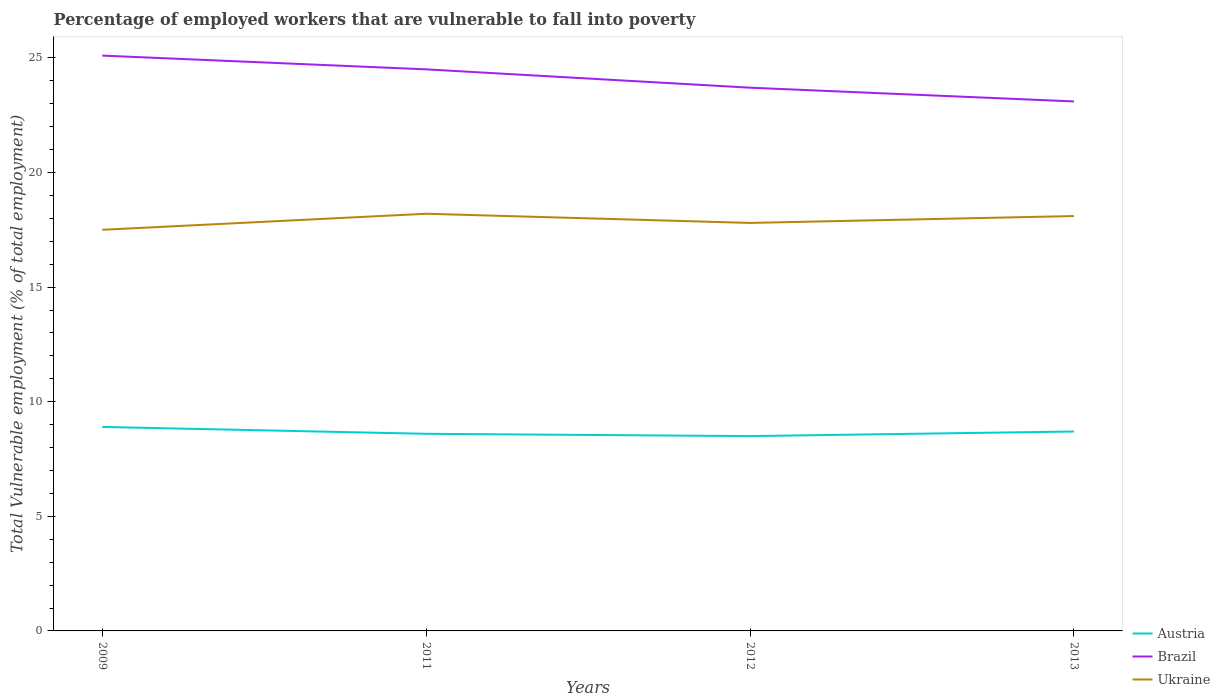Is the number of lines equal to the number of legend labels?
Provide a succinct answer. Yes. In which year was the percentage of employed workers who are vulnerable to fall into poverty in Austria maximum?
Your response must be concise. 2012. What is the total percentage of employed workers who are vulnerable to fall into poverty in Austria in the graph?
Offer a terse response. 0.1. What is the difference between the highest and the second highest percentage of employed workers who are vulnerable to fall into poverty in Ukraine?
Ensure brevity in your answer.  0.7. Is the percentage of employed workers who are vulnerable to fall into poverty in Austria strictly greater than the percentage of employed workers who are vulnerable to fall into poverty in Brazil over the years?
Your response must be concise. Yes. How many years are there in the graph?
Ensure brevity in your answer.  4. Are the values on the major ticks of Y-axis written in scientific E-notation?
Ensure brevity in your answer.  No. Does the graph contain grids?
Your answer should be very brief. No. How many legend labels are there?
Keep it short and to the point. 3. What is the title of the graph?
Offer a terse response. Percentage of employed workers that are vulnerable to fall into poverty. Does "Hong Kong" appear as one of the legend labels in the graph?
Offer a terse response. No. What is the label or title of the Y-axis?
Provide a short and direct response. Total Vulnerable employment (% of total employment). What is the Total Vulnerable employment (% of total employment) of Austria in 2009?
Make the answer very short. 8.9. What is the Total Vulnerable employment (% of total employment) of Brazil in 2009?
Provide a succinct answer. 25.1. What is the Total Vulnerable employment (% of total employment) of Ukraine in 2009?
Give a very brief answer. 17.5. What is the Total Vulnerable employment (% of total employment) in Austria in 2011?
Your response must be concise. 8.6. What is the Total Vulnerable employment (% of total employment) in Ukraine in 2011?
Ensure brevity in your answer.  18.2. What is the Total Vulnerable employment (% of total employment) in Brazil in 2012?
Offer a very short reply. 23.7. What is the Total Vulnerable employment (% of total employment) of Ukraine in 2012?
Your response must be concise. 17.8. What is the Total Vulnerable employment (% of total employment) in Austria in 2013?
Make the answer very short. 8.7. What is the Total Vulnerable employment (% of total employment) of Brazil in 2013?
Provide a succinct answer. 23.1. What is the Total Vulnerable employment (% of total employment) in Ukraine in 2013?
Your answer should be compact. 18.1. Across all years, what is the maximum Total Vulnerable employment (% of total employment) of Austria?
Keep it short and to the point. 8.9. Across all years, what is the maximum Total Vulnerable employment (% of total employment) in Brazil?
Keep it short and to the point. 25.1. Across all years, what is the maximum Total Vulnerable employment (% of total employment) in Ukraine?
Make the answer very short. 18.2. Across all years, what is the minimum Total Vulnerable employment (% of total employment) of Brazil?
Offer a terse response. 23.1. What is the total Total Vulnerable employment (% of total employment) in Austria in the graph?
Your answer should be very brief. 34.7. What is the total Total Vulnerable employment (% of total employment) of Brazil in the graph?
Your answer should be very brief. 96.4. What is the total Total Vulnerable employment (% of total employment) in Ukraine in the graph?
Your answer should be compact. 71.6. What is the difference between the Total Vulnerable employment (% of total employment) of Austria in 2009 and that in 2011?
Your response must be concise. 0.3. What is the difference between the Total Vulnerable employment (% of total employment) of Ukraine in 2009 and that in 2011?
Offer a terse response. -0.7. What is the difference between the Total Vulnerable employment (% of total employment) in Brazil in 2009 and that in 2012?
Offer a very short reply. 1.4. What is the difference between the Total Vulnerable employment (% of total employment) in Austria in 2009 and that in 2013?
Offer a terse response. 0.2. What is the difference between the Total Vulnerable employment (% of total employment) of Austria in 2011 and that in 2013?
Provide a succinct answer. -0.1. What is the difference between the Total Vulnerable employment (% of total employment) in Ukraine in 2011 and that in 2013?
Ensure brevity in your answer.  0.1. What is the difference between the Total Vulnerable employment (% of total employment) of Austria in 2012 and that in 2013?
Provide a short and direct response. -0.2. What is the difference between the Total Vulnerable employment (% of total employment) of Austria in 2009 and the Total Vulnerable employment (% of total employment) of Brazil in 2011?
Make the answer very short. -15.6. What is the difference between the Total Vulnerable employment (% of total employment) in Austria in 2009 and the Total Vulnerable employment (% of total employment) in Ukraine in 2011?
Ensure brevity in your answer.  -9.3. What is the difference between the Total Vulnerable employment (% of total employment) of Austria in 2009 and the Total Vulnerable employment (% of total employment) of Brazil in 2012?
Offer a terse response. -14.8. What is the difference between the Total Vulnerable employment (% of total employment) in Austria in 2009 and the Total Vulnerable employment (% of total employment) in Ukraine in 2012?
Give a very brief answer. -8.9. What is the difference between the Total Vulnerable employment (% of total employment) in Austria in 2009 and the Total Vulnerable employment (% of total employment) in Brazil in 2013?
Make the answer very short. -14.2. What is the difference between the Total Vulnerable employment (% of total employment) in Austria in 2009 and the Total Vulnerable employment (% of total employment) in Ukraine in 2013?
Give a very brief answer. -9.2. What is the difference between the Total Vulnerable employment (% of total employment) in Brazil in 2009 and the Total Vulnerable employment (% of total employment) in Ukraine in 2013?
Provide a succinct answer. 7. What is the difference between the Total Vulnerable employment (% of total employment) of Austria in 2011 and the Total Vulnerable employment (% of total employment) of Brazil in 2012?
Offer a terse response. -15.1. What is the difference between the Total Vulnerable employment (% of total employment) in Brazil in 2011 and the Total Vulnerable employment (% of total employment) in Ukraine in 2012?
Your response must be concise. 6.7. What is the difference between the Total Vulnerable employment (% of total employment) of Austria in 2012 and the Total Vulnerable employment (% of total employment) of Brazil in 2013?
Your answer should be very brief. -14.6. What is the average Total Vulnerable employment (% of total employment) of Austria per year?
Offer a very short reply. 8.68. What is the average Total Vulnerable employment (% of total employment) in Brazil per year?
Provide a succinct answer. 24.1. What is the average Total Vulnerable employment (% of total employment) in Ukraine per year?
Your answer should be compact. 17.9. In the year 2009, what is the difference between the Total Vulnerable employment (% of total employment) of Austria and Total Vulnerable employment (% of total employment) of Brazil?
Provide a succinct answer. -16.2. In the year 2009, what is the difference between the Total Vulnerable employment (% of total employment) of Brazil and Total Vulnerable employment (% of total employment) of Ukraine?
Your answer should be very brief. 7.6. In the year 2011, what is the difference between the Total Vulnerable employment (% of total employment) of Austria and Total Vulnerable employment (% of total employment) of Brazil?
Your response must be concise. -15.9. In the year 2011, what is the difference between the Total Vulnerable employment (% of total employment) in Austria and Total Vulnerable employment (% of total employment) in Ukraine?
Give a very brief answer. -9.6. In the year 2012, what is the difference between the Total Vulnerable employment (% of total employment) of Austria and Total Vulnerable employment (% of total employment) of Brazil?
Ensure brevity in your answer.  -15.2. In the year 2012, what is the difference between the Total Vulnerable employment (% of total employment) in Austria and Total Vulnerable employment (% of total employment) in Ukraine?
Offer a very short reply. -9.3. In the year 2013, what is the difference between the Total Vulnerable employment (% of total employment) in Austria and Total Vulnerable employment (% of total employment) in Brazil?
Offer a terse response. -14.4. In the year 2013, what is the difference between the Total Vulnerable employment (% of total employment) of Austria and Total Vulnerable employment (% of total employment) of Ukraine?
Keep it short and to the point. -9.4. What is the ratio of the Total Vulnerable employment (% of total employment) of Austria in 2009 to that in 2011?
Provide a short and direct response. 1.03. What is the ratio of the Total Vulnerable employment (% of total employment) of Brazil in 2009 to that in 2011?
Provide a succinct answer. 1.02. What is the ratio of the Total Vulnerable employment (% of total employment) in Ukraine in 2009 to that in 2011?
Provide a succinct answer. 0.96. What is the ratio of the Total Vulnerable employment (% of total employment) in Austria in 2009 to that in 2012?
Give a very brief answer. 1.05. What is the ratio of the Total Vulnerable employment (% of total employment) of Brazil in 2009 to that in 2012?
Keep it short and to the point. 1.06. What is the ratio of the Total Vulnerable employment (% of total employment) in Ukraine in 2009 to that in 2012?
Give a very brief answer. 0.98. What is the ratio of the Total Vulnerable employment (% of total employment) of Brazil in 2009 to that in 2013?
Give a very brief answer. 1.09. What is the ratio of the Total Vulnerable employment (% of total employment) in Ukraine in 2009 to that in 2013?
Give a very brief answer. 0.97. What is the ratio of the Total Vulnerable employment (% of total employment) of Austria in 2011 to that in 2012?
Keep it short and to the point. 1.01. What is the ratio of the Total Vulnerable employment (% of total employment) in Brazil in 2011 to that in 2012?
Your answer should be very brief. 1.03. What is the ratio of the Total Vulnerable employment (% of total employment) of Ukraine in 2011 to that in 2012?
Keep it short and to the point. 1.02. What is the ratio of the Total Vulnerable employment (% of total employment) in Austria in 2011 to that in 2013?
Provide a succinct answer. 0.99. What is the ratio of the Total Vulnerable employment (% of total employment) in Brazil in 2011 to that in 2013?
Ensure brevity in your answer.  1.06. What is the ratio of the Total Vulnerable employment (% of total employment) in Ukraine in 2011 to that in 2013?
Provide a short and direct response. 1.01. What is the ratio of the Total Vulnerable employment (% of total employment) of Ukraine in 2012 to that in 2013?
Your answer should be compact. 0.98. What is the difference between the highest and the second highest Total Vulnerable employment (% of total employment) of Brazil?
Your answer should be compact. 0.6. What is the difference between the highest and the second highest Total Vulnerable employment (% of total employment) of Ukraine?
Keep it short and to the point. 0.1. What is the difference between the highest and the lowest Total Vulnerable employment (% of total employment) in Austria?
Provide a succinct answer. 0.4. 